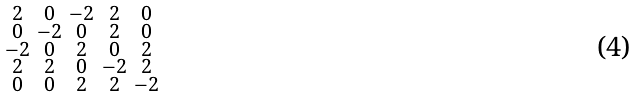Convert formula to latex. <formula><loc_0><loc_0><loc_500><loc_500>\begin{smallmatrix} 2 & 0 & - 2 & 2 & 0 \\ 0 & - 2 & 0 & 2 & 0 \\ - 2 & 0 & 2 & 0 & 2 \\ 2 & 2 & 0 & - 2 & 2 \\ 0 & 0 & 2 & 2 & - 2 \end{smallmatrix}</formula> 